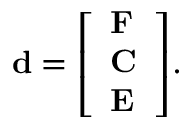Convert formula to latex. <formula><loc_0><loc_0><loc_500><loc_500>d = { \left [ \begin{array} { l } { F } \\ { C } \\ { E } \end{array} \right ] } .</formula> 